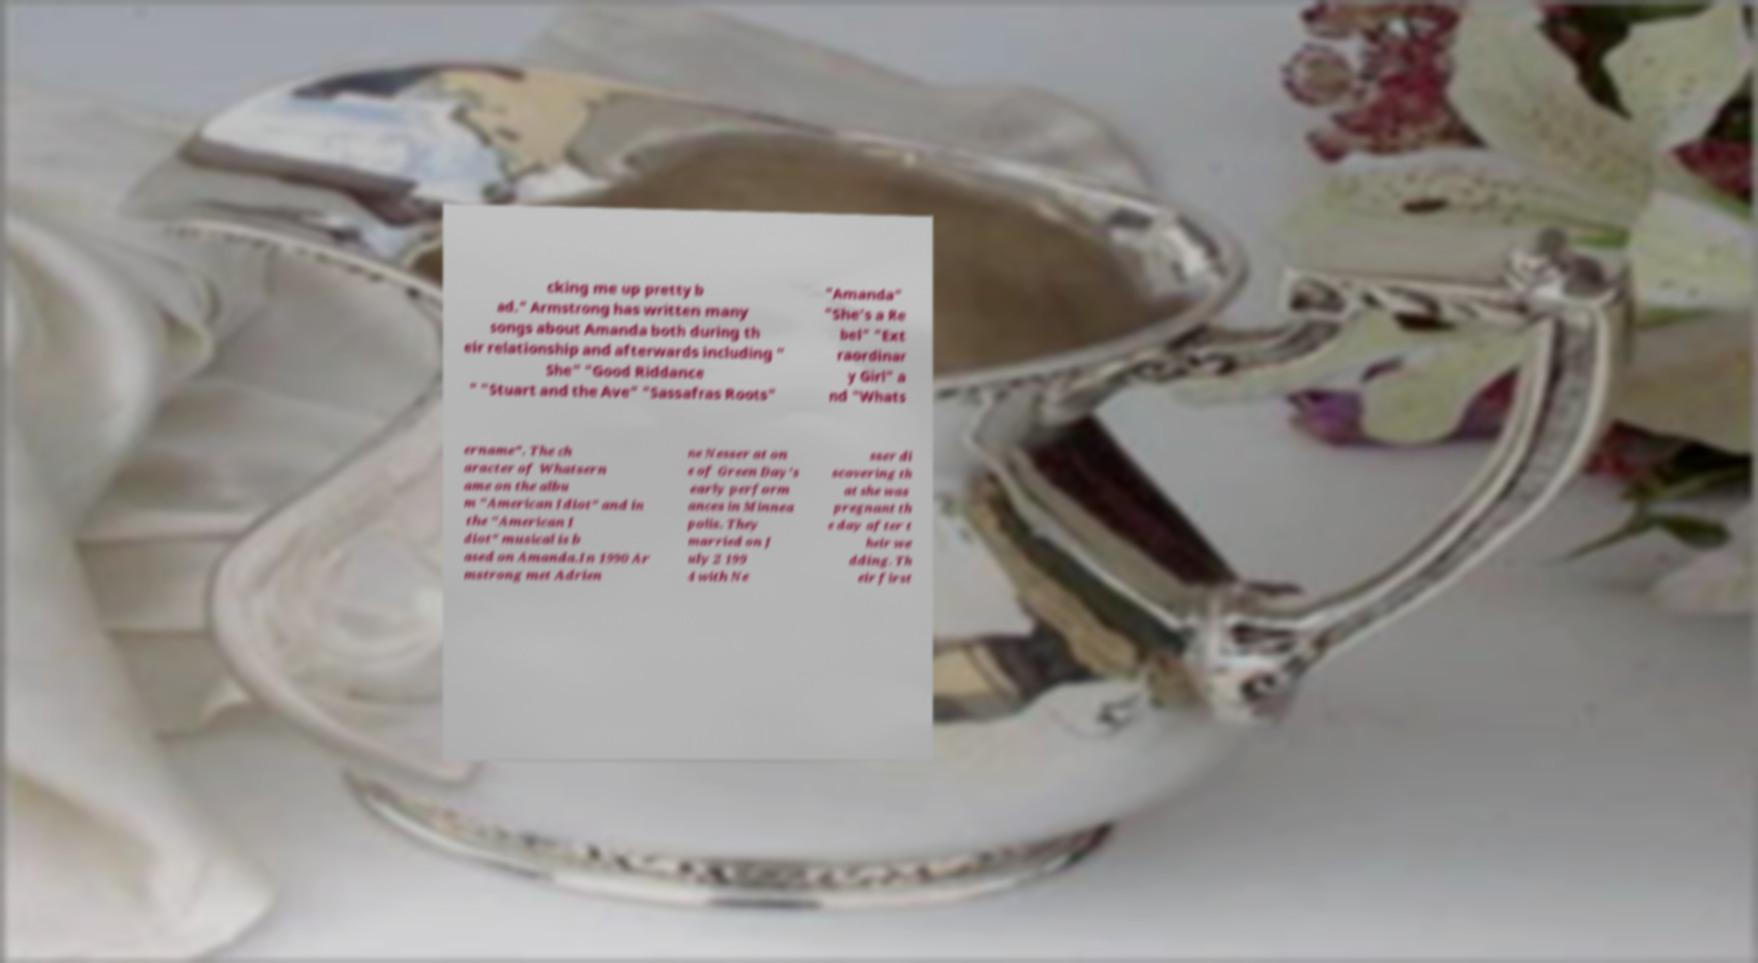For documentation purposes, I need the text within this image transcribed. Could you provide that? cking me up pretty b ad." Armstrong has written many songs about Amanda both during th eir relationship and afterwards including " She" "Good Riddance " "Stuart and the Ave" "Sassafras Roots" "Amanda" "She's a Re bel" "Ext raordinar y Girl" a nd "Whats ername". The ch aracter of Whatsern ame on the albu m "American Idiot" and in the "American I diot" musical is b ased on Amanda.In 1990 Ar mstrong met Adrien ne Nesser at on e of Green Day's early perform ances in Minnea polis. They married on J uly 2 199 4 with Ne sser di scovering th at she was pregnant th e day after t heir we dding. Th eir first 